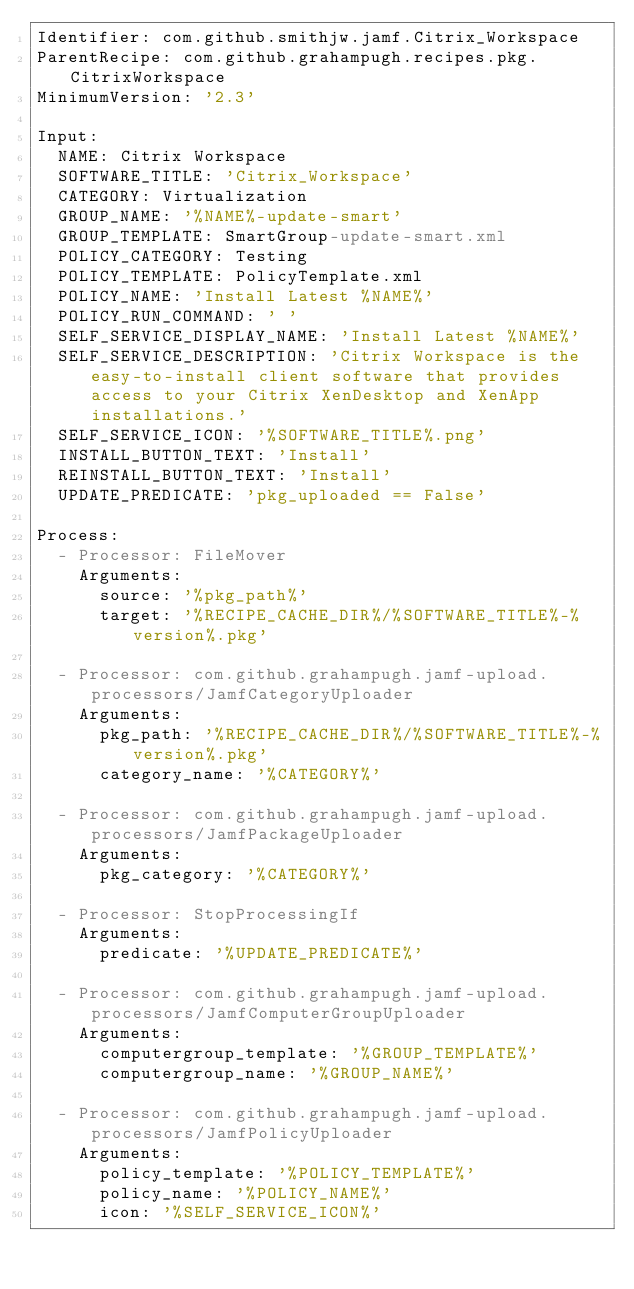Convert code to text. <code><loc_0><loc_0><loc_500><loc_500><_YAML_>Identifier: com.github.smithjw.jamf.Citrix_Workspace
ParentRecipe: com.github.grahampugh.recipes.pkg.CitrixWorkspace
MinimumVersion: '2.3'

Input:
  NAME: Citrix Workspace
  SOFTWARE_TITLE: 'Citrix_Workspace'
  CATEGORY: Virtualization
  GROUP_NAME: '%NAME%-update-smart'
  GROUP_TEMPLATE: SmartGroup-update-smart.xml
  POLICY_CATEGORY: Testing
  POLICY_TEMPLATE: PolicyTemplate.xml
  POLICY_NAME: 'Install Latest %NAME%'
  POLICY_RUN_COMMAND: ' '
  SELF_SERVICE_DISPLAY_NAME: 'Install Latest %NAME%'
  SELF_SERVICE_DESCRIPTION: 'Citrix Workspace is the easy-to-install client software that provides access to your Citrix XenDesktop and XenApp installations.'
  SELF_SERVICE_ICON: '%SOFTWARE_TITLE%.png'
  INSTALL_BUTTON_TEXT: 'Install'
  REINSTALL_BUTTON_TEXT: 'Install'
  UPDATE_PREDICATE: 'pkg_uploaded == False'

Process:
  - Processor: FileMover
    Arguments:
      source: '%pkg_path%'
      target: '%RECIPE_CACHE_DIR%/%SOFTWARE_TITLE%-%version%.pkg'

  - Processor: com.github.grahampugh.jamf-upload.processors/JamfCategoryUploader
    Arguments:
      pkg_path: '%RECIPE_CACHE_DIR%/%SOFTWARE_TITLE%-%version%.pkg'
      category_name: '%CATEGORY%'

  - Processor: com.github.grahampugh.jamf-upload.processors/JamfPackageUploader
    Arguments:
      pkg_category: '%CATEGORY%'

  - Processor: StopProcessingIf
    Arguments:
      predicate: '%UPDATE_PREDICATE%'

  - Processor: com.github.grahampugh.jamf-upload.processors/JamfComputerGroupUploader
    Arguments:
      computergroup_template: '%GROUP_TEMPLATE%'
      computergroup_name: '%GROUP_NAME%'

  - Processor: com.github.grahampugh.jamf-upload.processors/JamfPolicyUploader
    Arguments:
      policy_template: '%POLICY_TEMPLATE%'
      policy_name: '%POLICY_NAME%'
      icon: '%SELF_SERVICE_ICON%'
</code> 